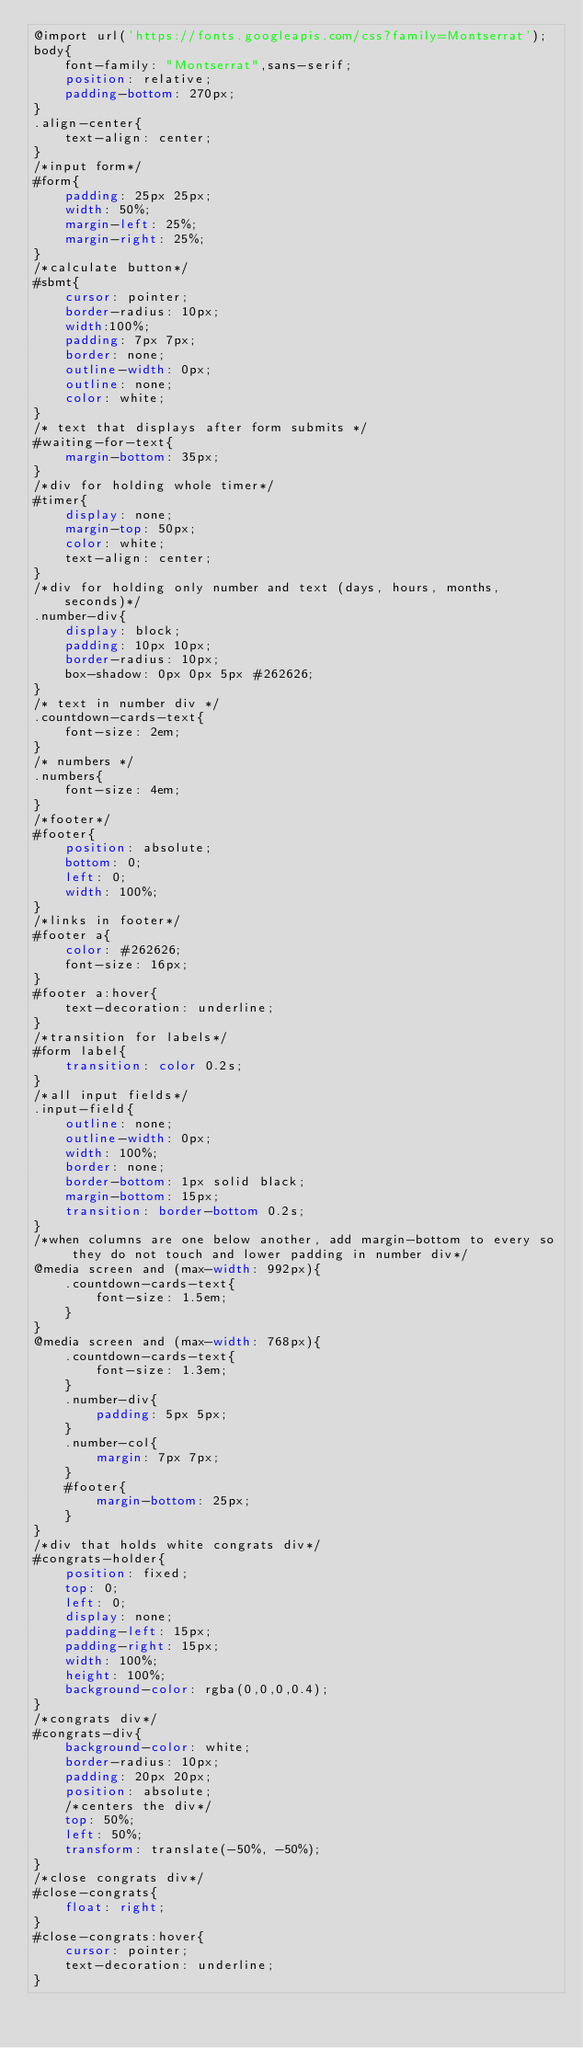<code> <loc_0><loc_0><loc_500><loc_500><_CSS_>@import url('https://fonts.googleapis.com/css?family=Montserrat');
body{
	font-family: "Montserrat",sans-serif;
	position: relative;
	padding-bottom: 270px;
}
.align-center{
	text-align: center;
}
/*input form*/
#form{
	padding: 25px 25px;
	width: 50%;
	margin-left: 25%;
	margin-right: 25%;
}
/*calculate button*/
#sbmt{
	cursor: pointer;
	border-radius: 10px;
	width:100%;
	padding: 7px 7px;
	border: none;
	outline-width: 0px;
	outline: none;
	color: white;
}
/* text that displays after form submits */
#waiting-for-text{
	margin-bottom: 35px;
}
/*div for holding whole timer*/
#timer{
	display: none;
	margin-top: 50px;
	color: white;
	text-align: center;
}
/*div for holding only number and text (days, hours, months, seconds)*/
.number-div{
	display: block;
	padding: 10px 10px;
	border-radius: 10px;
	box-shadow: 0px 0px 5px #262626;
}
/* text in number div */
.countdown-cards-text{
	font-size: 2em;
}
/* numbers */
.numbers{
	font-size: 4em;
}
/*footer*/
#footer{
	position: absolute;
	bottom: 0;
	left: 0;
	width: 100%;
}
/*links in footer*/
#footer a{
	color: #262626;
	font-size: 16px;
}
#footer a:hover{
	text-decoration: underline;
}
/*transition for labels*/
#form label{
	transition: color 0.2s;
}
/*all input fields*/
.input-field{
	outline: none;
	outline-width: 0px;
	width: 100%;
	border: none;
	border-bottom: 1px solid black;
	margin-bottom: 15px;
	transition: border-bottom 0.2s;
}
/*when columns are one below another, add margin-bottom to every so they do not touch and lower padding in number div*/
@media screen and (max-width: 992px){
	.countdown-cards-text{
		font-size: 1.5em;
	}
}
@media screen and (max-width: 768px){
	.countdown-cards-text{
		font-size: 1.3em;
	}
	.number-div{
		padding: 5px 5px;
	}
	.number-col{
		margin: 7px 7px;
	}
	#footer{
		margin-bottom: 25px;
	}
}
/*div that holds white congrats div*/
#congrats-holder{
	position: fixed;
	top: 0;
	left: 0;
	display: none;
	padding-left: 15px;
	padding-right: 15px;
	width: 100%;
	height: 100%;
	background-color: rgba(0,0,0,0.4);
}
/*congrats div*/
#congrats-div{
	background-color: white;
	border-radius: 10px;
	padding: 20px 20px;
	position: absolute;
	/*centers the div*/
	top: 50%;
	left: 50%;
	transform: translate(-50%, -50%);
}
/*close congrats div*/
#close-congrats{
	float: right;
}
#close-congrats:hover{
	cursor: pointer;
	text-decoration: underline; 
}</code> 